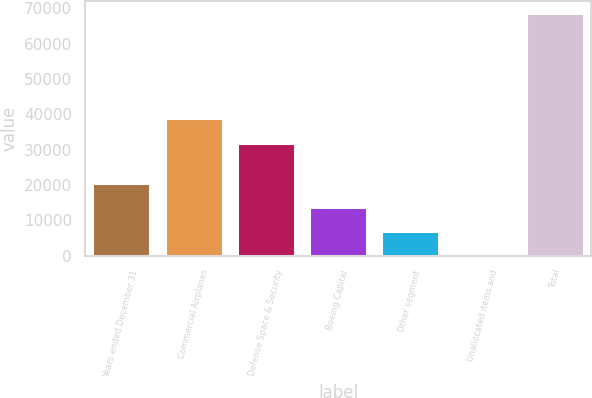Convert chart to OTSL. <chart><loc_0><loc_0><loc_500><loc_500><bar_chart><fcel>Years ended December 31<fcel>Commercial Airplanes<fcel>Defense Space & Security<fcel>Boeing Capital<fcel>Other segment<fcel>Unallocated items and<fcel>Total<nl><fcel>20677.9<fcel>38841.3<fcel>31976<fcel>13812.6<fcel>6947.3<fcel>82<fcel>68735<nl></chart> 